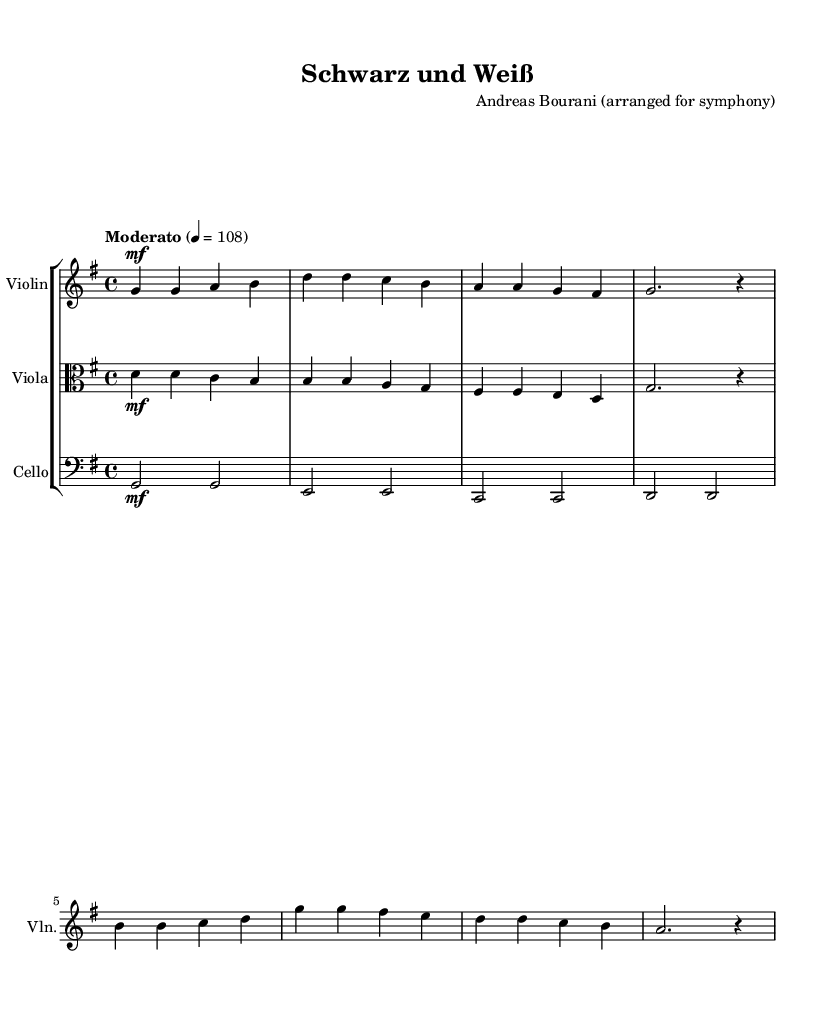What is the key signature of this music? The key signature is G major, which has one sharp (F#). This is indicated by the key signature shown at the beginning of the score.
Answer: G major What is the time signature of this music? The time signature is 4/4, which means there are four beats in each measure and the quarter note receives one beat. This is indicated at the beginning of the score next to the clef.
Answer: 4/4 What tempo marking is indicated in the score? The tempo marking is "Moderato," which signifies a moderate tempo. The metronome marking of 4 = 108 shows that there should be 108 quarter note beats per minute.
Answer: Moderato How many measures does the violin part contain? The violin part contains eight measures, which can be counted by identifying the vertical bar lines that separate the measures in the music.
Answer: Eight What is the dynamic marking for the main theme in the violin part? The dynamic marking for the main theme is "mf," which stands for "mezzo forte," indicating a moderately loud volume. It is indicated at the beginning of the violin part for the main theme notes.
Answer: mf What is the instrument that plays the countermelody? The instrument that plays the countermelody is the viola. This can be identified by the specific staff and clef used for this part in the score.
Answer: Viola What chord progression is indicated in the cello part? The chord progression in the cello part is G, E, C, D. This can be derived from the root notes indicated in the measures for the cello.
Answer: G, E, C, D 